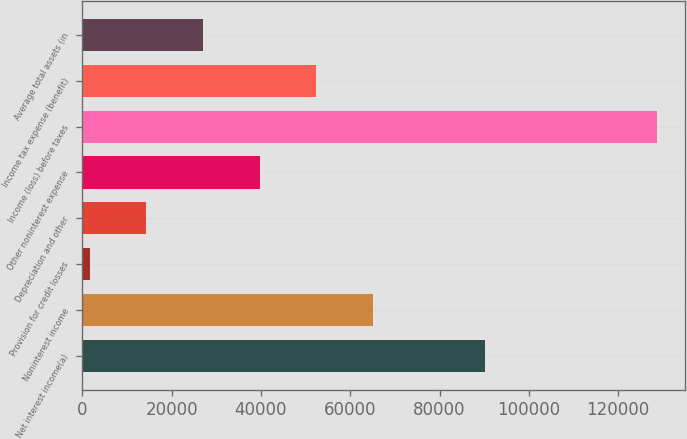<chart> <loc_0><loc_0><loc_500><loc_500><bar_chart><fcel>Net interest income(a)<fcel>Noninterest income<fcel>Provision for credit losses<fcel>Depreciation and other<fcel>Other noninterest expense<fcel>Income (loss) before taxes<fcel>Income tax expense (benefit)<fcel>Average total assets (in<nl><fcel>90204<fcel>65108<fcel>1608<fcel>14308<fcel>39708<fcel>128608<fcel>52408<fcel>27008<nl></chart> 